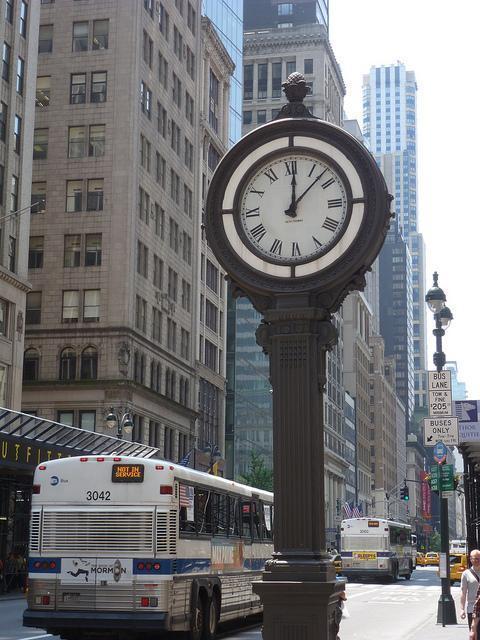How many buses can be seen?
Give a very brief answer. 2. How many clocks are there?
Give a very brief answer. 1. How many bottles of soap are by the sinks?
Give a very brief answer. 0. 